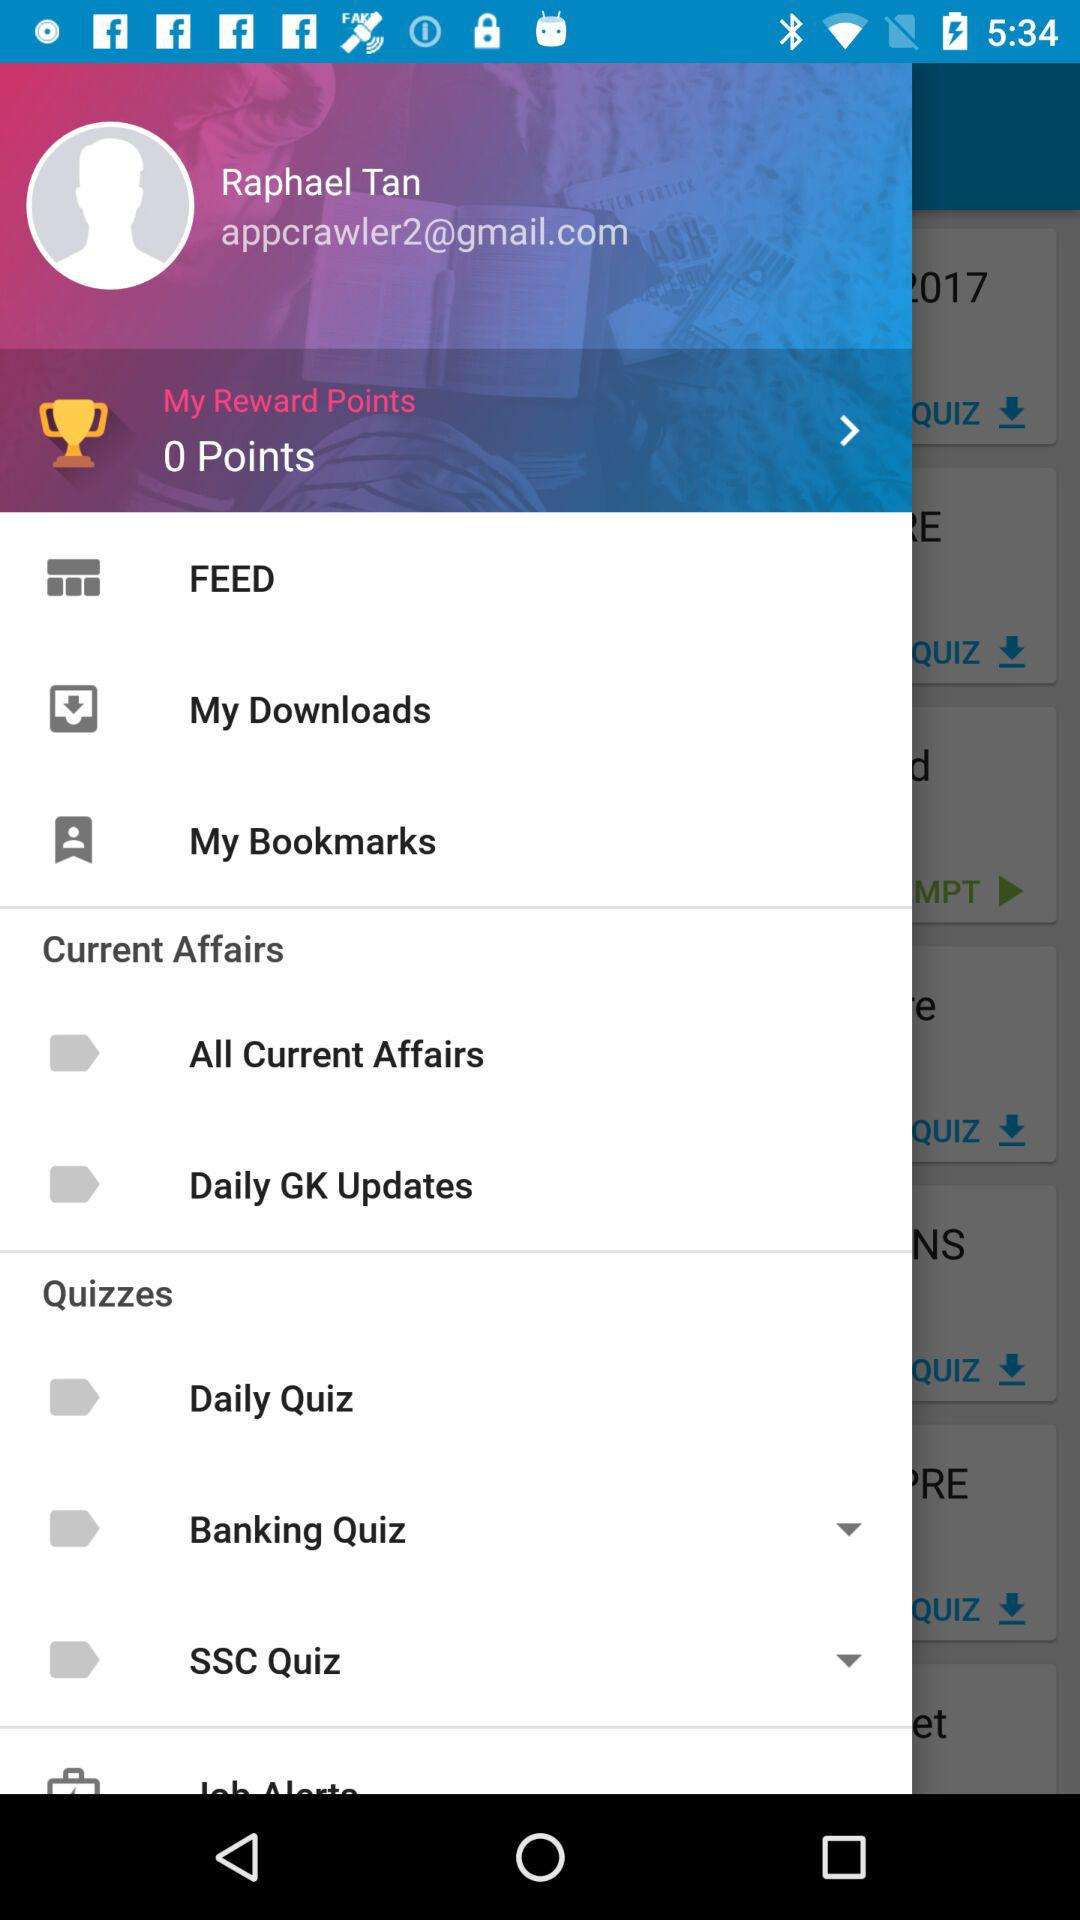How many points are there? There are 0 points. 